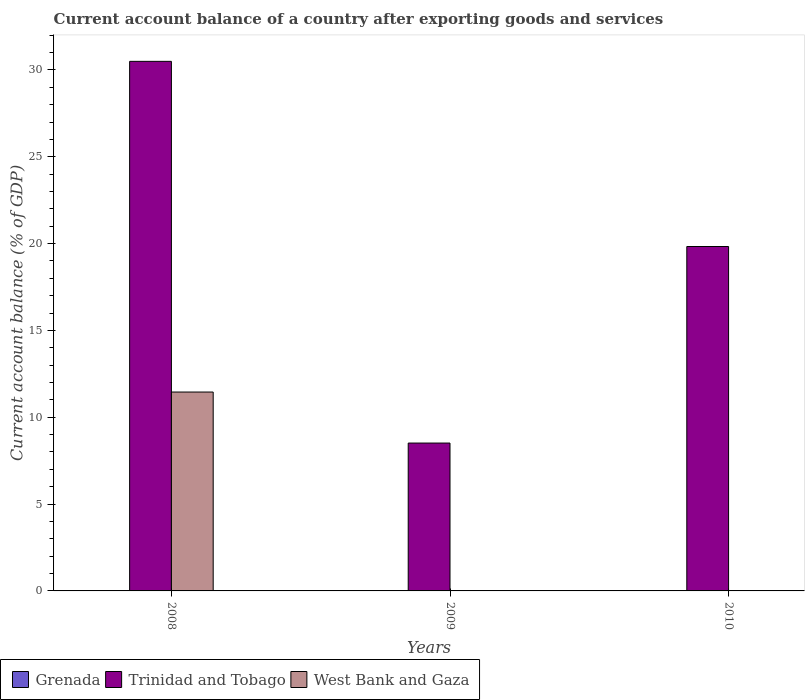Are the number of bars per tick equal to the number of legend labels?
Keep it short and to the point. No. Are the number of bars on each tick of the X-axis equal?
Make the answer very short. No. How many bars are there on the 3rd tick from the left?
Ensure brevity in your answer.  1. In how many cases, is the number of bars for a given year not equal to the number of legend labels?
Your answer should be compact. 3. What is the account balance in Trinidad and Tobago in 2009?
Your answer should be very brief. 8.52. Across all years, what is the maximum account balance in Trinidad and Tobago?
Offer a very short reply. 30.5. Across all years, what is the minimum account balance in West Bank and Gaza?
Give a very brief answer. 0. What is the total account balance in West Bank and Gaza in the graph?
Provide a short and direct response. 11.45. What is the difference between the account balance in Trinidad and Tobago in 2008 and that in 2010?
Offer a terse response. 10.66. What is the difference between the account balance in West Bank and Gaza in 2008 and the account balance in Grenada in 2010?
Provide a succinct answer. 11.45. What is the average account balance in Grenada per year?
Your response must be concise. 0. In the year 2008, what is the difference between the account balance in Trinidad and Tobago and account balance in West Bank and Gaza?
Your response must be concise. 19.04. In how many years, is the account balance in Trinidad and Tobago greater than 2 %?
Provide a short and direct response. 3. What is the ratio of the account balance in Trinidad and Tobago in 2008 to that in 2009?
Offer a terse response. 3.58. What is the difference between the highest and the second highest account balance in Trinidad and Tobago?
Your response must be concise. 10.66. What is the difference between the highest and the lowest account balance in West Bank and Gaza?
Offer a terse response. 11.45. How many bars are there?
Ensure brevity in your answer.  4. Are all the bars in the graph horizontal?
Offer a terse response. No. Are the values on the major ticks of Y-axis written in scientific E-notation?
Make the answer very short. No. How are the legend labels stacked?
Your answer should be compact. Horizontal. What is the title of the graph?
Ensure brevity in your answer.  Current account balance of a country after exporting goods and services. Does "Nepal" appear as one of the legend labels in the graph?
Your answer should be very brief. No. What is the label or title of the Y-axis?
Ensure brevity in your answer.  Current account balance (% of GDP). What is the Current account balance (% of GDP) of Trinidad and Tobago in 2008?
Your response must be concise. 30.5. What is the Current account balance (% of GDP) in West Bank and Gaza in 2008?
Provide a short and direct response. 11.45. What is the Current account balance (% of GDP) of Trinidad and Tobago in 2009?
Your answer should be very brief. 8.52. What is the Current account balance (% of GDP) of Grenada in 2010?
Make the answer very short. 0. What is the Current account balance (% of GDP) in Trinidad and Tobago in 2010?
Ensure brevity in your answer.  19.83. What is the Current account balance (% of GDP) in West Bank and Gaza in 2010?
Make the answer very short. 0. Across all years, what is the maximum Current account balance (% of GDP) in Trinidad and Tobago?
Keep it short and to the point. 30.5. Across all years, what is the maximum Current account balance (% of GDP) of West Bank and Gaza?
Ensure brevity in your answer.  11.45. Across all years, what is the minimum Current account balance (% of GDP) in Trinidad and Tobago?
Offer a very short reply. 8.52. Across all years, what is the minimum Current account balance (% of GDP) of West Bank and Gaza?
Make the answer very short. 0. What is the total Current account balance (% of GDP) in Grenada in the graph?
Keep it short and to the point. 0. What is the total Current account balance (% of GDP) in Trinidad and Tobago in the graph?
Give a very brief answer. 58.84. What is the total Current account balance (% of GDP) in West Bank and Gaza in the graph?
Your response must be concise. 11.45. What is the difference between the Current account balance (% of GDP) of Trinidad and Tobago in 2008 and that in 2009?
Your answer should be compact. 21.98. What is the difference between the Current account balance (% of GDP) in Trinidad and Tobago in 2008 and that in 2010?
Your response must be concise. 10.66. What is the difference between the Current account balance (% of GDP) of Trinidad and Tobago in 2009 and that in 2010?
Make the answer very short. -11.32. What is the average Current account balance (% of GDP) in Trinidad and Tobago per year?
Give a very brief answer. 19.61. What is the average Current account balance (% of GDP) in West Bank and Gaza per year?
Keep it short and to the point. 3.82. In the year 2008, what is the difference between the Current account balance (% of GDP) of Trinidad and Tobago and Current account balance (% of GDP) of West Bank and Gaza?
Keep it short and to the point. 19.04. What is the ratio of the Current account balance (% of GDP) in Trinidad and Tobago in 2008 to that in 2009?
Provide a succinct answer. 3.58. What is the ratio of the Current account balance (% of GDP) in Trinidad and Tobago in 2008 to that in 2010?
Make the answer very short. 1.54. What is the ratio of the Current account balance (% of GDP) of Trinidad and Tobago in 2009 to that in 2010?
Offer a terse response. 0.43. What is the difference between the highest and the second highest Current account balance (% of GDP) in Trinidad and Tobago?
Your answer should be compact. 10.66. What is the difference between the highest and the lowest Current account balance (% of GDP) in Trinidad and Tobago?
Provide a short and direct response. 21.98. What is the difference between the highest and the lowest Current account balance (% of GDP) in West Bank and Gaza?
Your answer should be very brief. 11.45. 